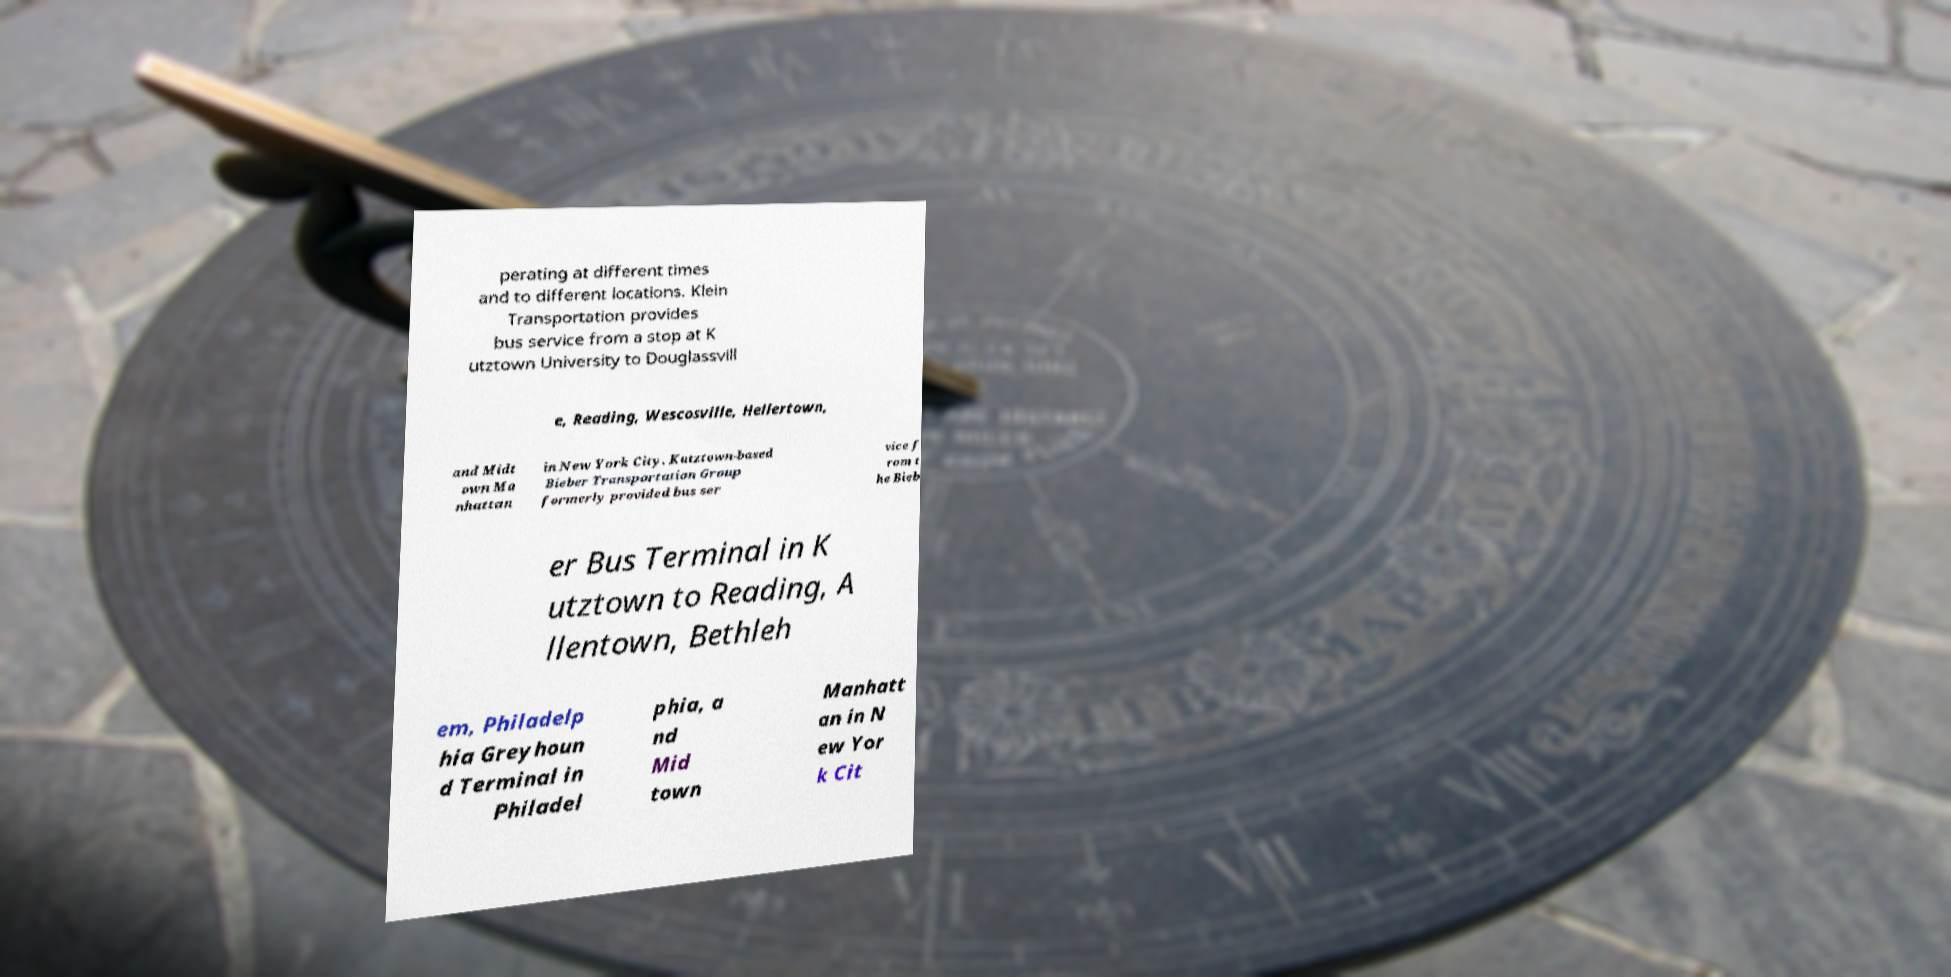There's text embedded in this image that I need extracted. Can you transcribe it verbatim? perating at different times and to different locations. Klein Transportation provides bus service from a stop at K utztown University to Douglassvill e, Reading, Wescosville, Hellertown, and Midt own Ma nhattan in New York City. Kutztown-based Bieber Transportation Group formerly provided bus ser vice f rom t he Bieb er Bus Terminal in K utztown to Reading, A llentown, Bethleh em, Philadelp hia Greyhoun d Terminal in Philadel phia, a nd Mid town Manhatt an in N ew Yor k Cit 